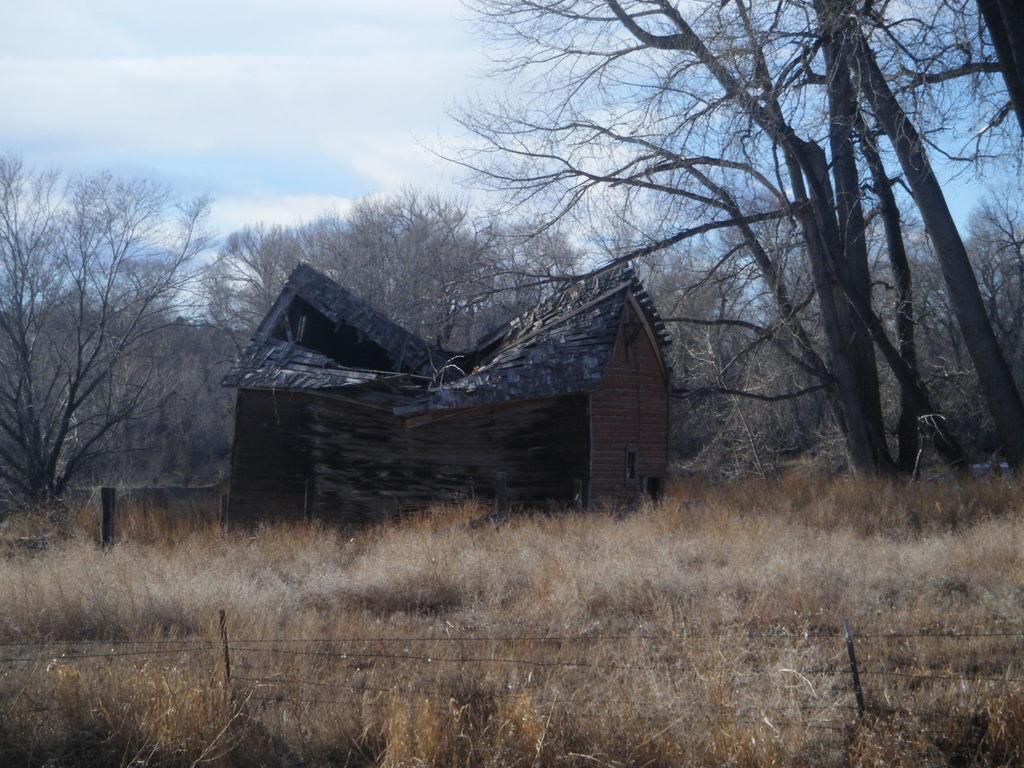Can you describe this image briefly? In this image we can see tents, trees, plants, dry grass and fences. In the background we can see the sky.  